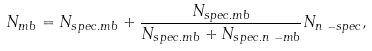<formula> <loc_0><loc_0><loc_500><loc_500>N _ { m b } = N _ { s p e c . m b } + \frac { N _ { s p e c . m b } } { N _ { s p e c . m b } + N _ { s p e c . n \mathchar ` - m b } } N _ { n \mathchar ` - s p e c } ,</formula> 